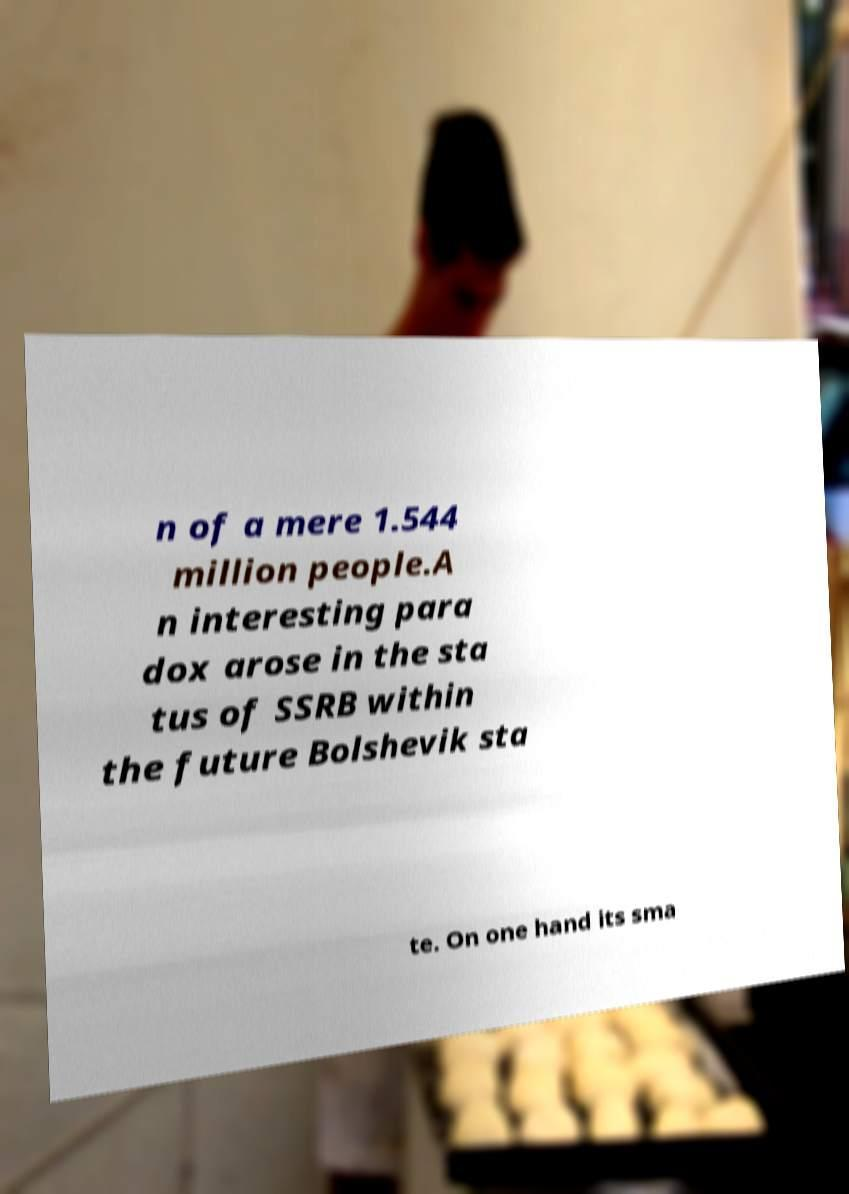What messages or text are displayed in this image? I need them in a readable, typed format. n of a mere 1.544 million people.A n interesting para dox arose in the sta tus of SSRB within the future Bolshevik sta te. On one hand its sma 